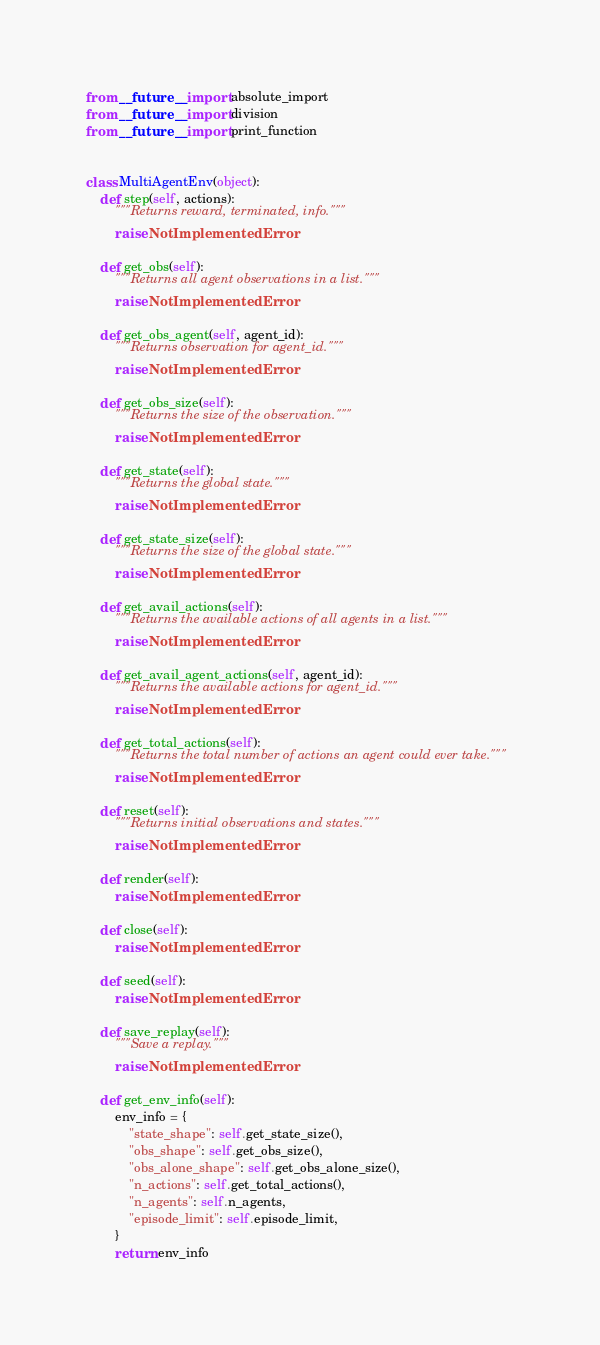<code> <loc_0><loc_0><loc_500><loc_500><_Python_>from __future__ import absolute_import
from __future__ import division
from __future__ import print_function


class MultiAgentEnv(object):
    def step(self, actions):
        """Returns reward, terminated, info."""
        raise NotImplementedError

    def get_obs(self):
        """Returns all agent observations in a list."""
        raise NotImplementedError

    def get_obs_agent(self, agent_id):
        """Returns observation for agent_id."""
        raise NotImplementedError

    def get_obs_size(self):
        """Returns the size of the observation."""
        raise NotImplementedError

    def get_state(self):
        """Returns the global state."""
        raise NotImplementedError

    def get_state_size(self):
        """Returns the size of the global state."""
        raise NotImplementedError

    def get_avail_actions(self):
        """Returns the available actions of all agents in a list."""
        raise NotImplementedError

    def get_avail_agent_actions(self, agent_id):
        """Returns the available actions for agent_id."""
        raise NotImplementedError

    def get_total_actions(self):
        """Returns the total number of actions an agent could ever take."""
        raise NotImplementedError

    def reset(self):
        """Returns initial observations and states."""
        raise NotImplementedError

    def render(self):
        raise NotImplementedError

    def close(self):
        raise NotImplementedError

    def seed(self):
        raise NotImplementedError

    def save_replay(self):
        """Save a replay."""
        raise NotImplementedError

    def get_env_info(self):
        env_info = {
            "state_shape": self.get_state_size(),
            "obs_shape": self.get_obs_size(),
            "obs_alone_shape": self.get_obs_alone_size(),
            "n_actions": self.get_total_actions(),
            "n_agents": self.n_agents,
            "episode_limit": self.episode_limit,
        }
        return env_info
</code> 